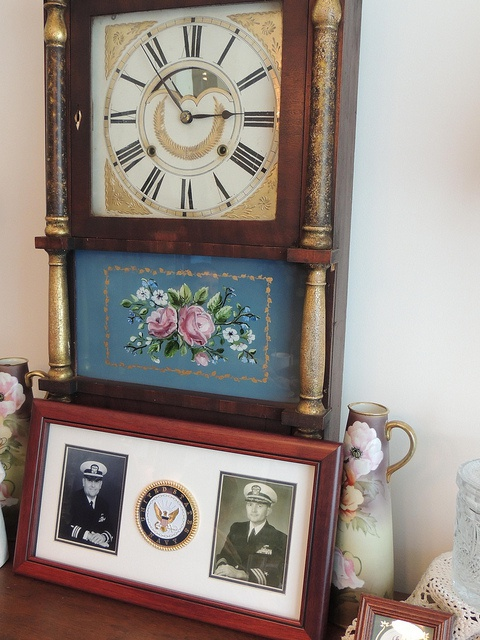Describe the objects in this image and their specific colors. I can see clock in lightgray, darkgray, tan, and gray tones, vase in lightgray, darkgray, black, and gray tones, people in lightgray, black, gray, and darkgray tones, vase in lightgray, black, gray, and darkgray tones, and tie in lightgray, gray, darkgreen, and black tones in this image. 